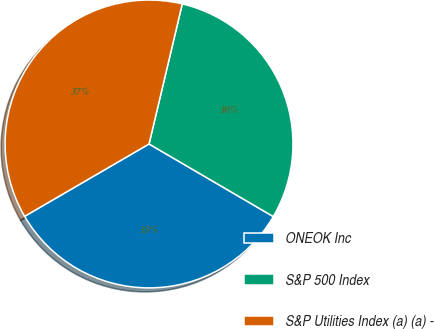<chart> <loc_0><loc_0><loc_500><loc_500><pie_chart><fcel>ONEOK Inc<fcel>S&P 500 Index<fcel>S&P Utilities Index (a) (a) -<nl><fcel>33.2%<fcel>29.71%<fcel>37.09%<nl></chart> 